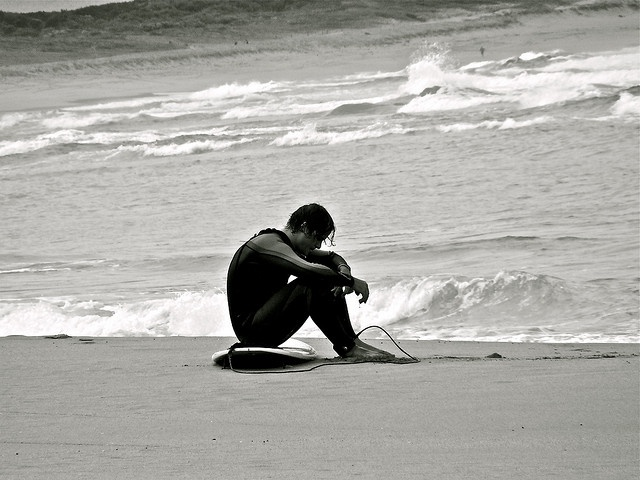Describe the objects in this image and their specific colors. I can see people in darkgray, black, gray, and white tones and surfboard in darkgray, black, white, and gray tones in this image. 